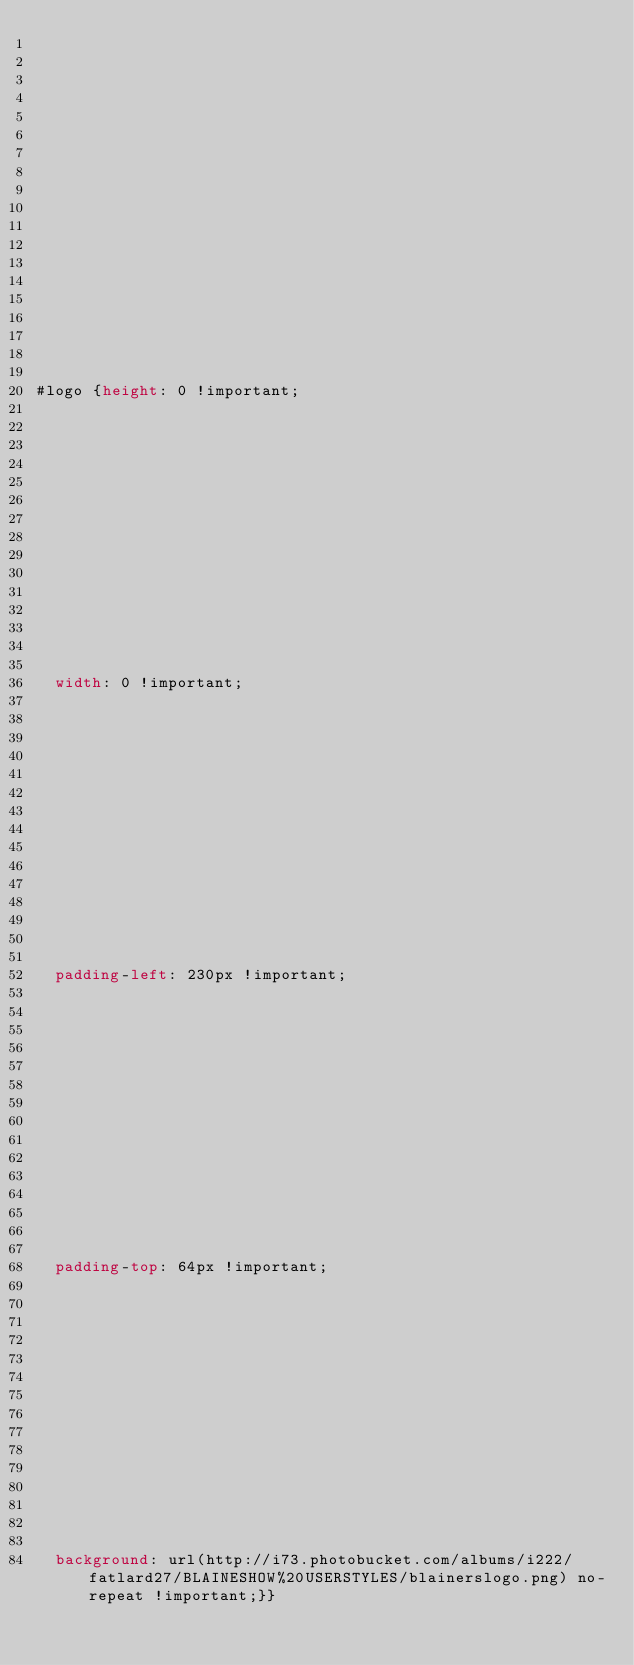<code> <loc_0><loc_0><loc_500><loc_500><_CSS_>


















#logo {height: 0 !important;















	width: 0 !important;















	padding-left: 230px !important;















	padding-top: 64px !important;















	background: url(http://i73.photobucket.com/albums/i222/fatlard27/BLAINESHOW%20USERSTYLES/blainerslogo.png) no-repeat !important;}}</code> 